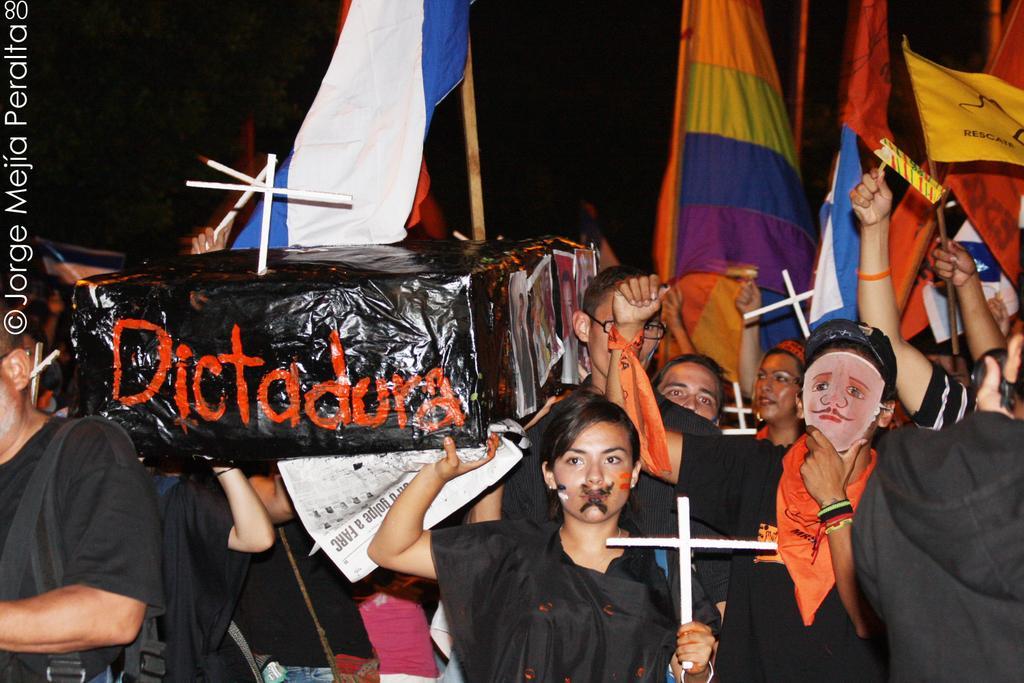How would you summarize this image in a sentence or two? There are group of people standing. Among them few people are holding holy cross symbols, flags and the box. The background looks like dark. This is the watermark on the image. 